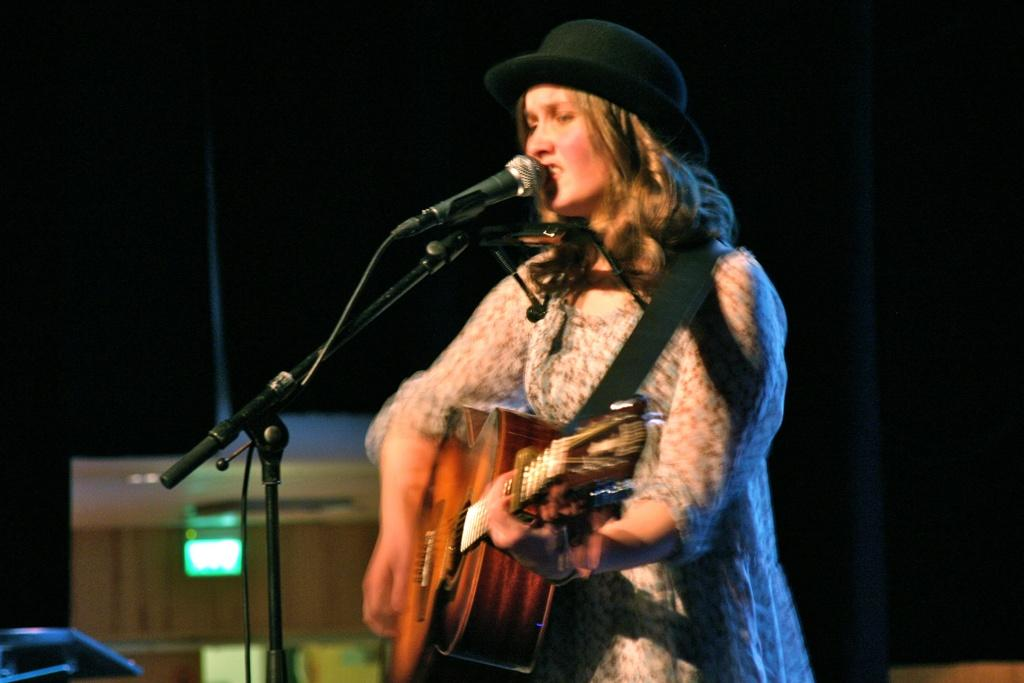Who is the main subject in the image? There is a woman in the image. What is the woman doing in the image? The woman is singing and playing a guitar. What is the woman positioned in front of? The woman is in front of a microphone. What can be seen in the background of the image? There is a light in the background of the image. How many bricks are visible in the image? There are no bricks present in the image. What time is displayed on the clock in the image? There is no clock present in the image. 